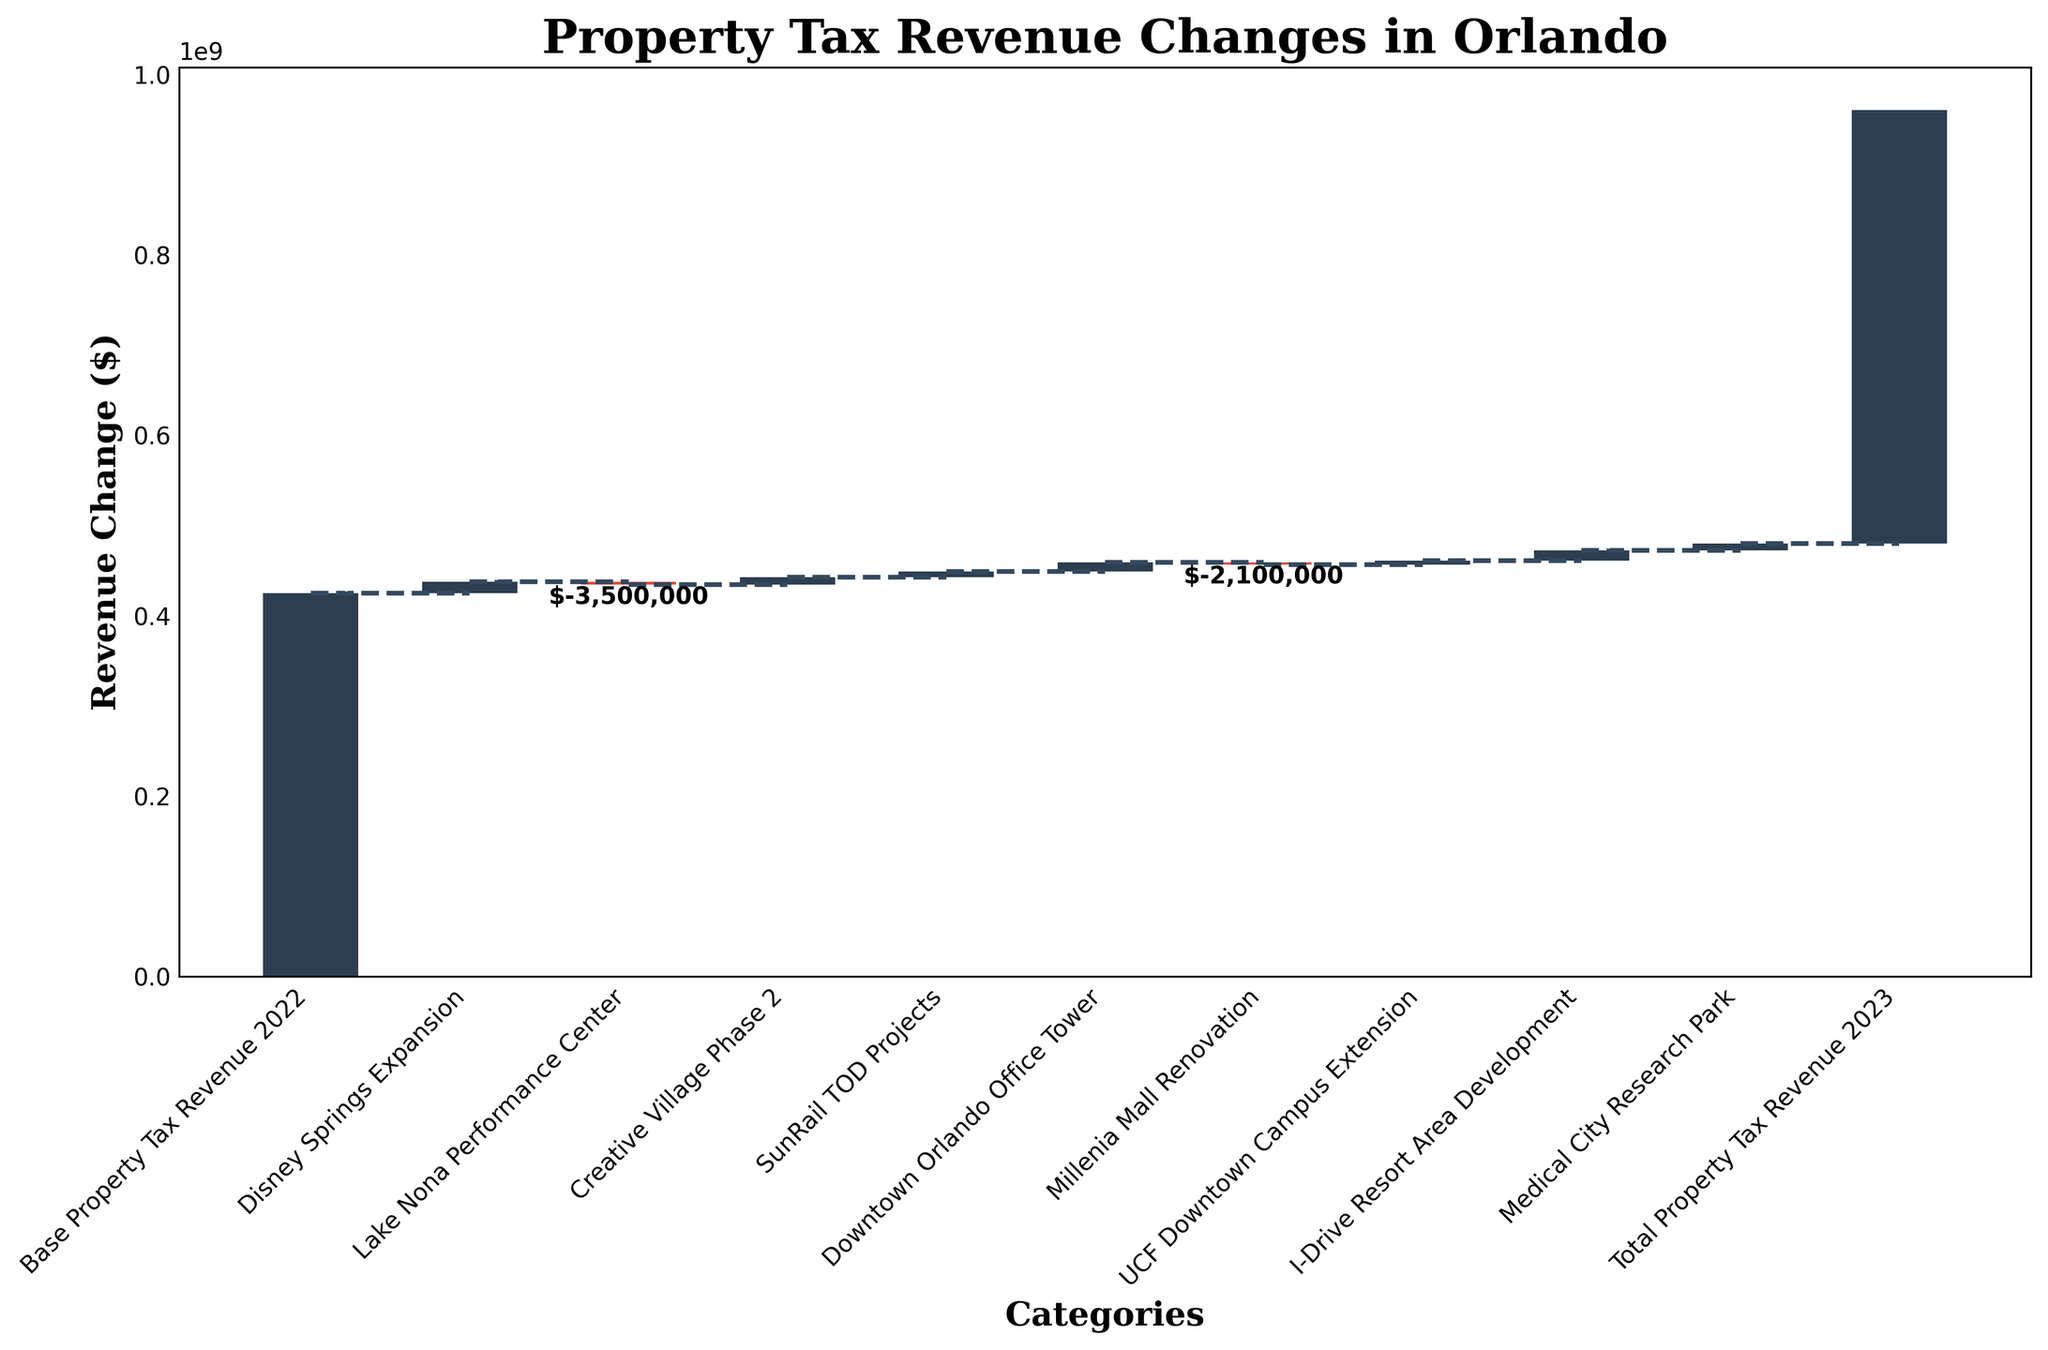What's the title of the chart? The title is usually placed at the top of the chart to give an overview of what the chart is about. In this chart, the title should summarize the content of the figure.
Answer: Property Tax Revenue Changes in Orlando What is the base property tax revenue for 2022? The base property tax revenue is indicated as the starting value on the chart before any changes are taken into account.
Answer: $425,000,000 Which category has the highest positive change in revenue? By looking at the height of the bars above the zero line in the waterfall chart, we can determine the highest positive change in revenue.
Answer: Disney Springs Expansion Which category has the largest negative impact on revenue? To find the largest negative impact, look for the bar that extends below the zero line the most.
Answer: Lake Nona Performance Center What is the total change in property tax revenue from 2022 to 2023? The total change is the difference between the base value and the end value. Subtract the base property tax revenue from the total property tax revenue for 2023.
Answer: $55,050,000 How does the revenue change attributed to the Downtown Orlando Office Tower compare to that of the SunRail TOD Projects? Compare the heights of the bars representing these two categories. The Downtown Orlando Office Tower has a greater height, indicating a larger positive revenue change.
Answer: Downtown Orlando Office Tower is larger What is the combined revenue change from the Creative Village Phase 2 and the UCF Downtown Campus Extension? Add the values associated with these two categories as indicated by their respective bars.
Answer: $13,050,000 How many categories are displayed in the waterfall chart? Count the individual bars, represented in different colors for positive and negative changes.
Answer: 10 What is the net impact of the Millenia Mall Renovation and the Medical City Research Park combined? Add the changes of these two categories, taking into account that one is positive and one is negative. Millenia Mall Renovation: -$2,100,000 Medical City Research Park: $7,600,000 Net Impact: 7,600,000 + (-2,100,000) = $5,500,000
Answer: $5,500,000 What is the visual color indication for positive and negative changes in revenue in the chart? Positive changes are usually indicated by one color while negative changes by another. In this chart, they can be identified by the bar colors.
Answer: Positive: dark blue, Negative: red 